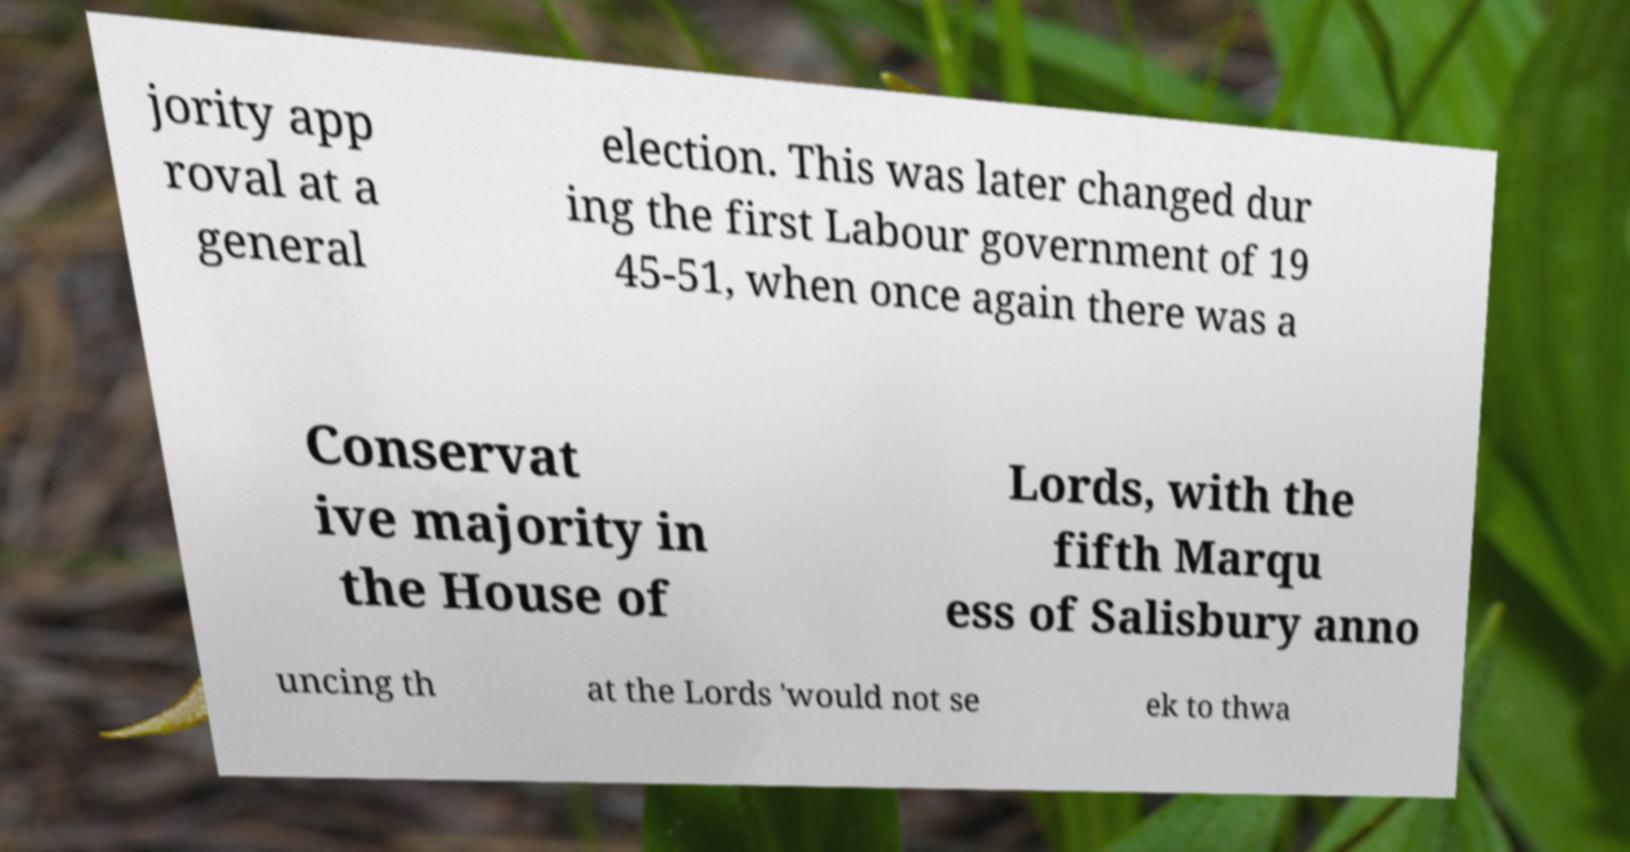Can you accurately transcribe the text from the provided image for me? jority app roval at a general election. This was later changed dur ing the first Labour government of 19 45-51, when once again there was a Conservat ive majority in the House of Lords, with the fifth Marqu ess of Salisbury anno uncing th at the Lords 'would not se ek to thwa 